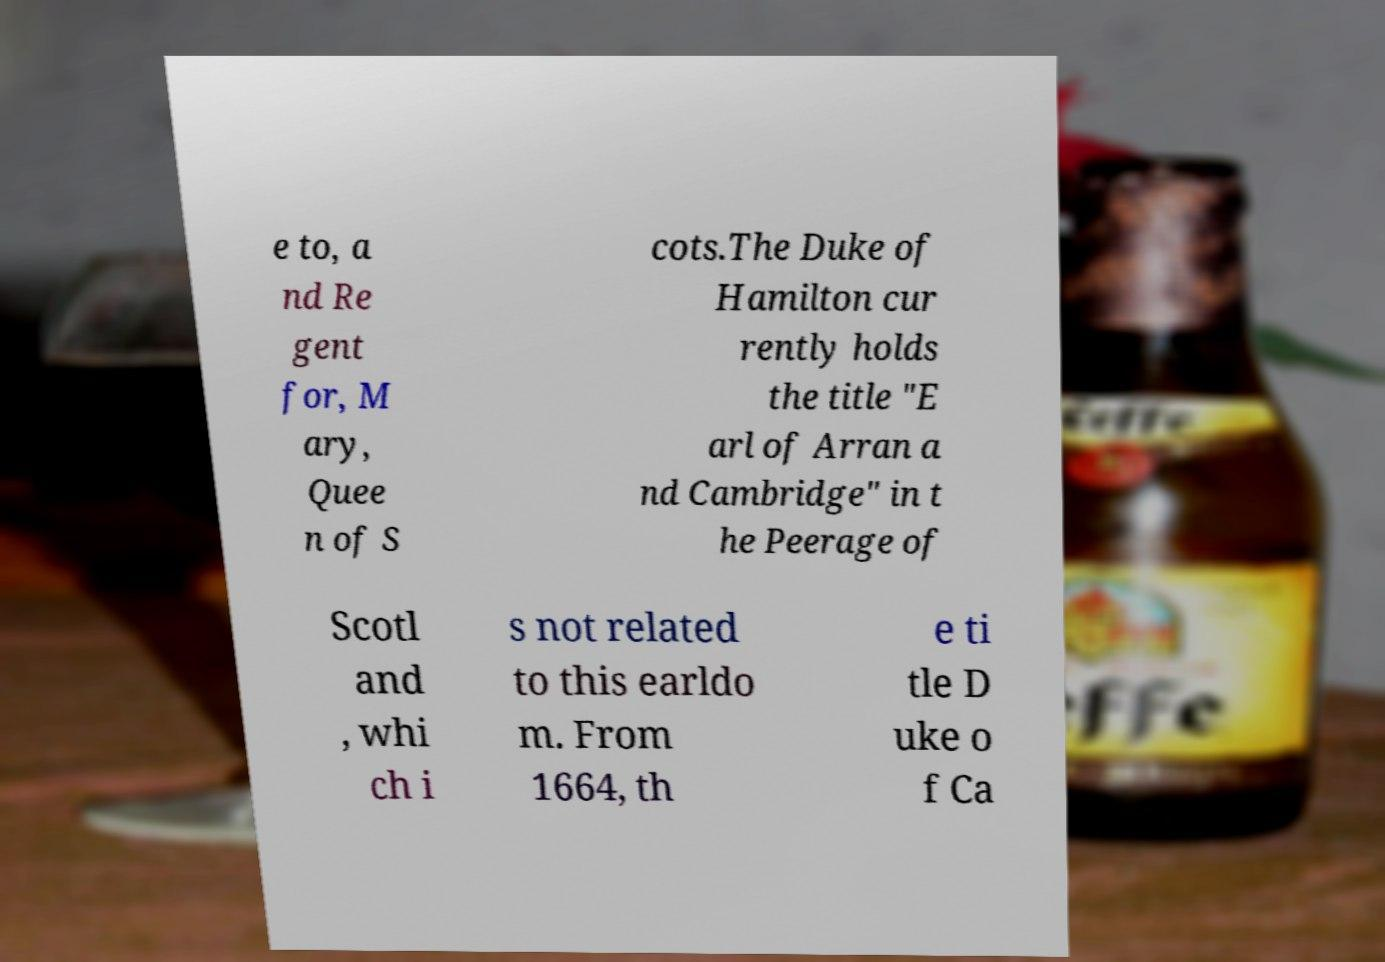Could you assist in decoding the text presented in this image and type it out clearly? e to, a nd Re gent for, M ary, Quee n of S cots.The Duke of Hamilton cur rently holds the title "E arl of Arran a nd Cambridge" in t he Peerage of Scotl and , whi ch i s not related to this earldo m. From 1664, th e ti tle D uke o f Ca 